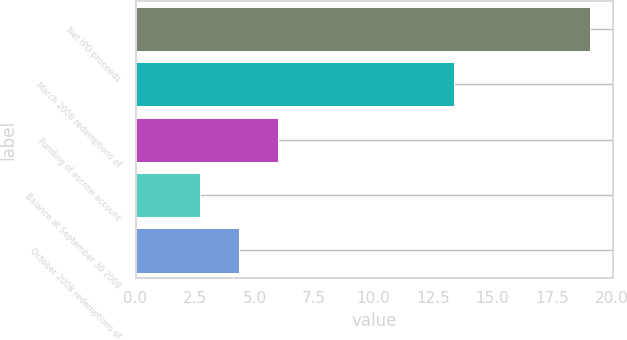<chart> <loc_0><loc_0><loc_500><loc_500><bar_chart><fcel>Net IPO proceeds<fcel>March 2008 redemptions of<fcel>Funding of escrow account<fcel>Balance at September 30 2008<fcel>October 2008 redemptions of<nl><fcel>19.1<fcel>13.4<fcel>5.98<fcel>2.7<fcel>4.34<nl></chart> 